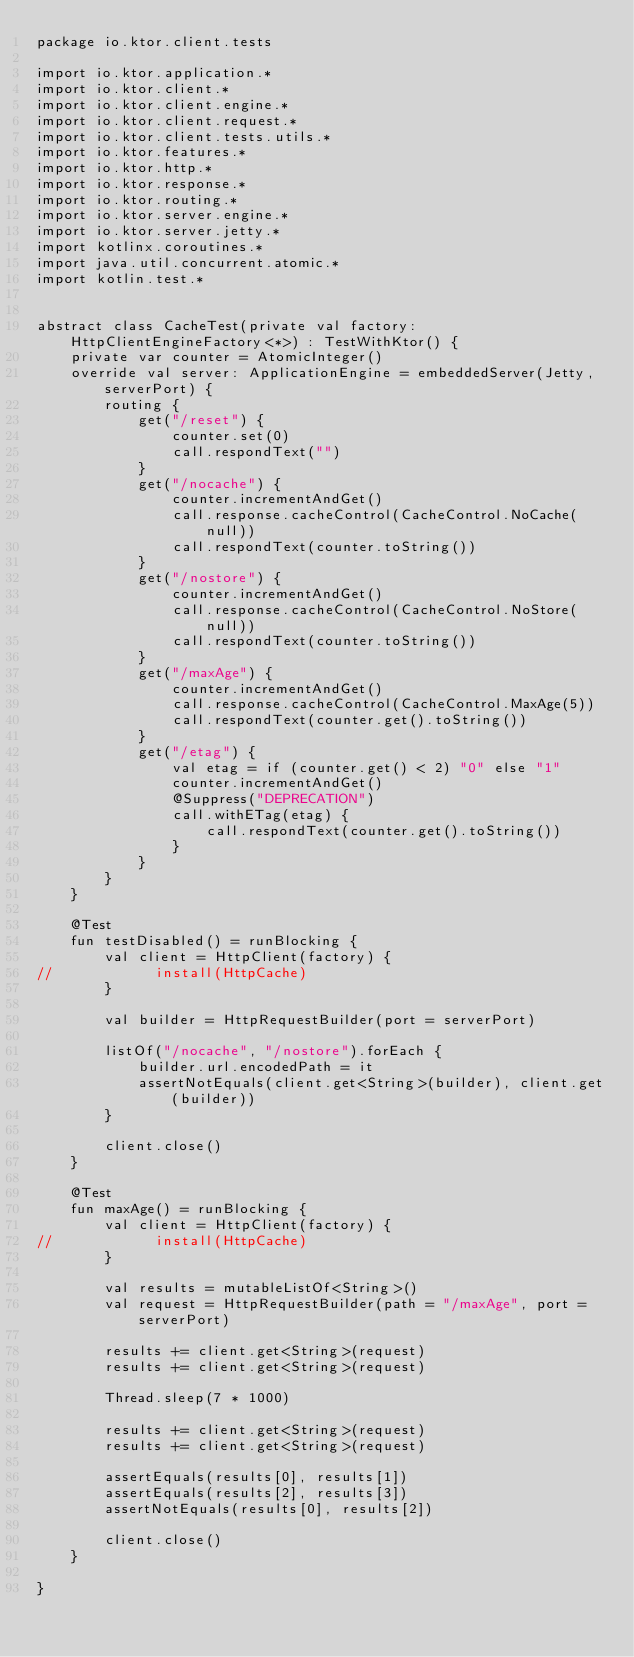<code> <loc_0><loc_0><loc_500><loc_500><_Kotlin_>package io.ktor.client.tests

import io.ktor.application.*
import io.ktor.client.*
import io.ktor.client.engine.*
import io.ktor.client.request.*
import io.ktor.client.tests.utils.*
import io.ktor.features.*
import io.ktor.http.*
import io.ktor.response.*
import io.ktor.routing.*
import io.ktor.server.engine.*
import io.ktor.server.jetty.*
import kotlinx.coroutines.*
import java.util.concurrent.atomic.*
import kotlin.test.*


abstract class CacheTest(private val factory: HttpClientEngineFactory<*>) : TestWithKtor() {
    private var counter = AtomicInteger()
    override val server: ApplicationEngine = embeddedServer(Jetty, serverPort) {
        routing {
            get("/reset") {
                counter.set(0)
                call.respondText("")
            }
            get("/nocache") {
                counter.incrementAndGet()
                call.response.cacheControl(CacheControl.NoCache(null))
                call.respondText(counter.toString())
            }
            get("/nostore") {
                counter.incrementAndGet()
                call.response.cacheControl(CacheControl.NoStore(null))
                call.respondText(counter.toString())
            }
            get("/maxAge") {
                counter.incrementAndGet()
                call.response.cacheControl(CacheControl.MaxAge(5))
                call.respondText(counter.get().toString())
            }
            get("/etag") {
                val etag = if (counter.get() < 2) "0" else "1"
                counter.incrementAndGet()
                @Suppress("DEPRECATION")
                call.withETag(etag) {
                    call.respondText(counter.get().toString())
                }
            }
        }
    }

    @Test
    fun testDisabled() = runBlocking {
        val client = HttpClient(factory) {
//            install(HttpCache)
        }

        val builder = HttpRequestBuilder(port = serverPort)

        listOf("/nocache", "/nostore").forEach {
            builder.url.encodedPath = it
            assertNotEquals(client.get<String>(builder), client.get(builder))
        }

        client.close()
    }

    @Test
    fun maxAge() = runBlocking {
        val client = HttpClient(factory) {
//            install(HttpCache)
        }

        val results = mutableListOf<String>()
        val request = HttpRequestBuilder(path = "/maxAge", port = serverPort)

        results += client.get<String>(request)
        results += client.get<String>(request)

        Thread.sleep(7 * 1000)

        results += client.get<String>(request)
        results += client.get<String>(request)

        assertEquals(results[0], results[1])
        assertEquals(results[2], results[3])
        assertNotEquals(results[0], results[2])

        client.close()
    }

}</code> 